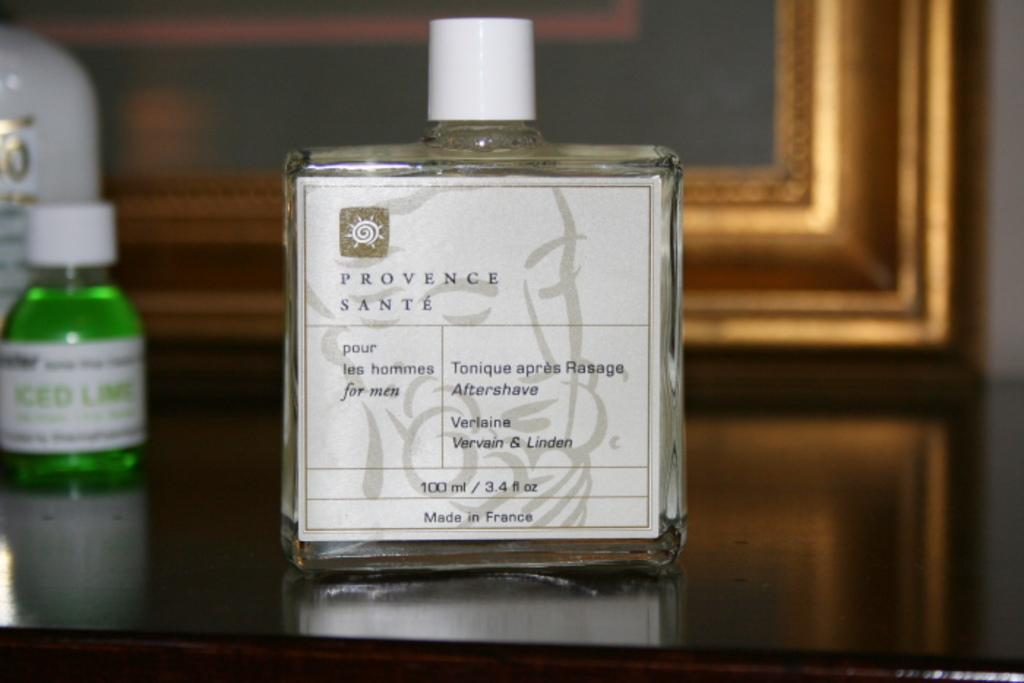<image>
Describe the image concisely. A bottle with a Provence Sante label is 100 ml . 